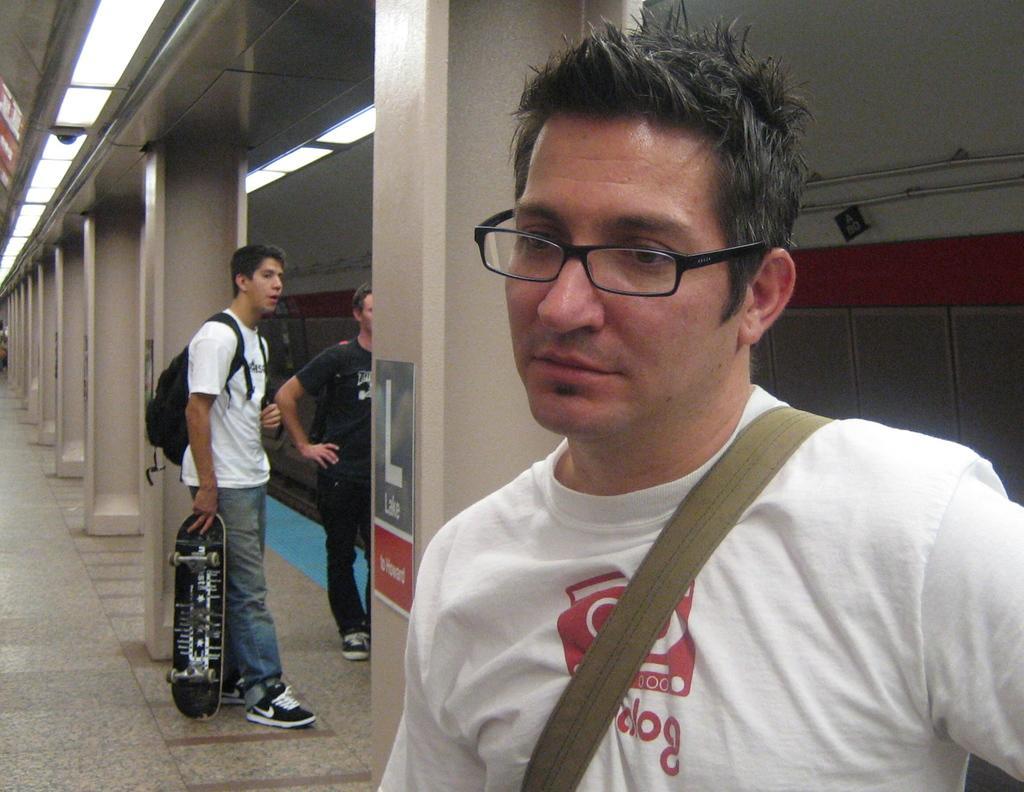Describe this image in one or two sentences. In this image, we can see three people. Here a person is holding a skateboard and wearing a backpack. Background we can see pillars, floor, glass, lights, pipes. 